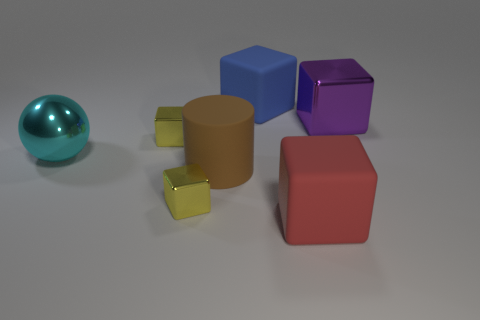The cyan metal object that is the same size as the purple shiny block is what shape?
Offer a very short reply. Sphere. Are there any other things that have the same shape as the brown object?
Give a very brief answer. No. What is the shape of the large brown thing that is to the left of the large shiny object that is behind the large metal thing left of the big red thing?
Ensure brevity in your answer.  Cylinder. What shape is the big cyan metal thing?
Your response must be concise. Sphere. What is the color of the shiny thing right of the red thing?
Ensure brevity in your answer.  Purple. There is a matte block in front of the cylinder; is its size the same as the cyan thing?
Your answer should be very brief. Yes. The blue thing that is the same shape as the large purple object is what size?
Give a very brief answer. Large. Does the big cyan shiny object have the same shape as the blue object?
Make the answer very short. No. Is the number of red rubber objects that are to the left of the large red block less than the number of large matte things in front of the big purple cube?
Keep it short and to the point. Yes. There is a large red block; what number of blocks are behind it?
Keep it short and to the point. 4. 